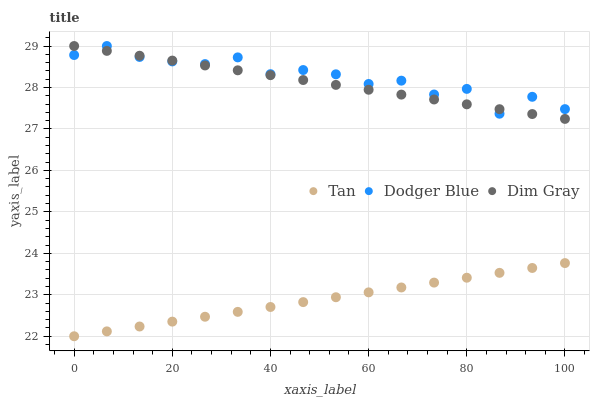Does Tan have the minimum area under the curve?
Answer yes or no. Yes. Does Dodger Blue have the maximum area under the curve?
Answer yes or no. Yes. Does Dim Gray have the minimum area under the curve?
Answer yes or no. No. Does Dim Gray have the maximum area under the curve?
Answer yes or no. No. Is Tan the smoothest?
Answer yes or no. Yes. Is Dodger Blue the roughest?
Answer yes or no. Yes. Is Dim Gray the smoothest?
Answer yes or no. No. Is Dim Gray the roughest?
Answer yes or no. No. Does Tan have the lowest value?
Answer yes or no. Yes. Does Dim Gray have the lowest value?
Answer yes or no. No. Does Dodger Blue have the highest value?
Answer yes or no. Yes. Is Tan less than Dim Gray?
Answer yes or no. Yes. Is Dim Gray greater than Tan?
Answer yes or no. Yes. Does Dodger Blue intersect Dim Gray?
Answer yes or no. Yes. Is Dodger Blue less than Dim Gray?
Answer yes or no. No. Is Dodger Blue greater than Dim Gray?
Answer yes or no. No. Does Tan intersect Dim Gray?
Answer yes or no. No. 